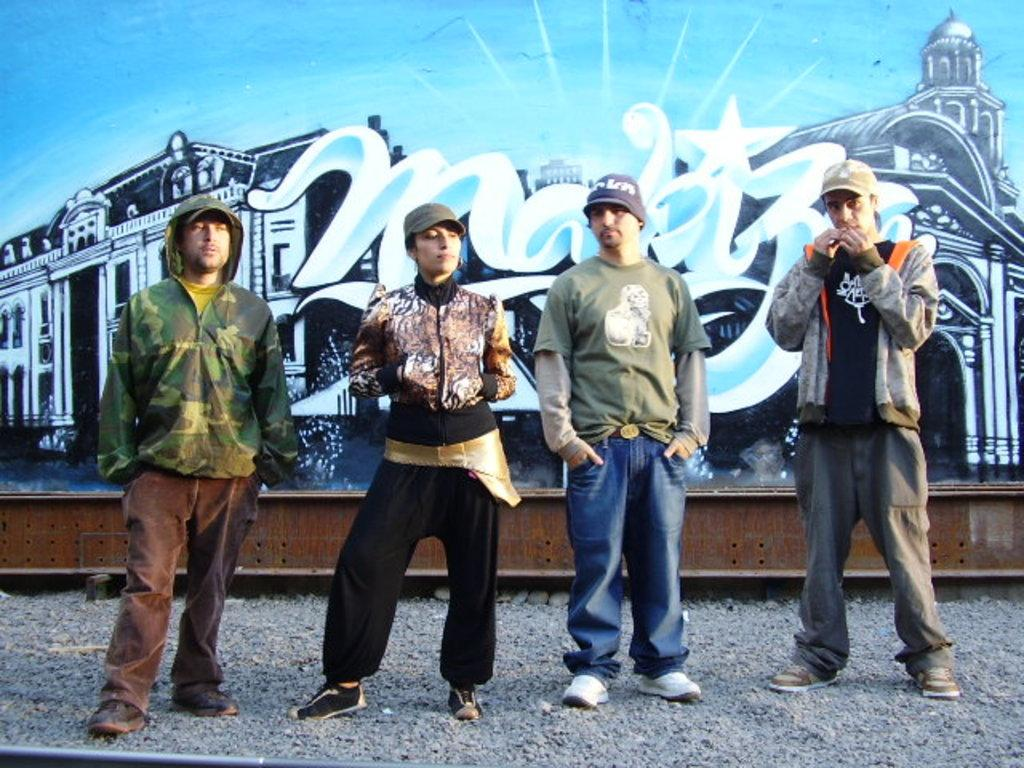How many people are present in the image? There are four people standing in the image. What are the people wearing on their heads? All of them are wearing caps. What type of clothing are three of the people wearing? Three of them are wearing jackets. What can be seen in the background of the image? There is graffiti visible in the background of the image. What type of nut is being used to generate heat in the image? There is no nut or heat generation present in the image. How many stars can be seen in the image? There are no stars visible in the image. 